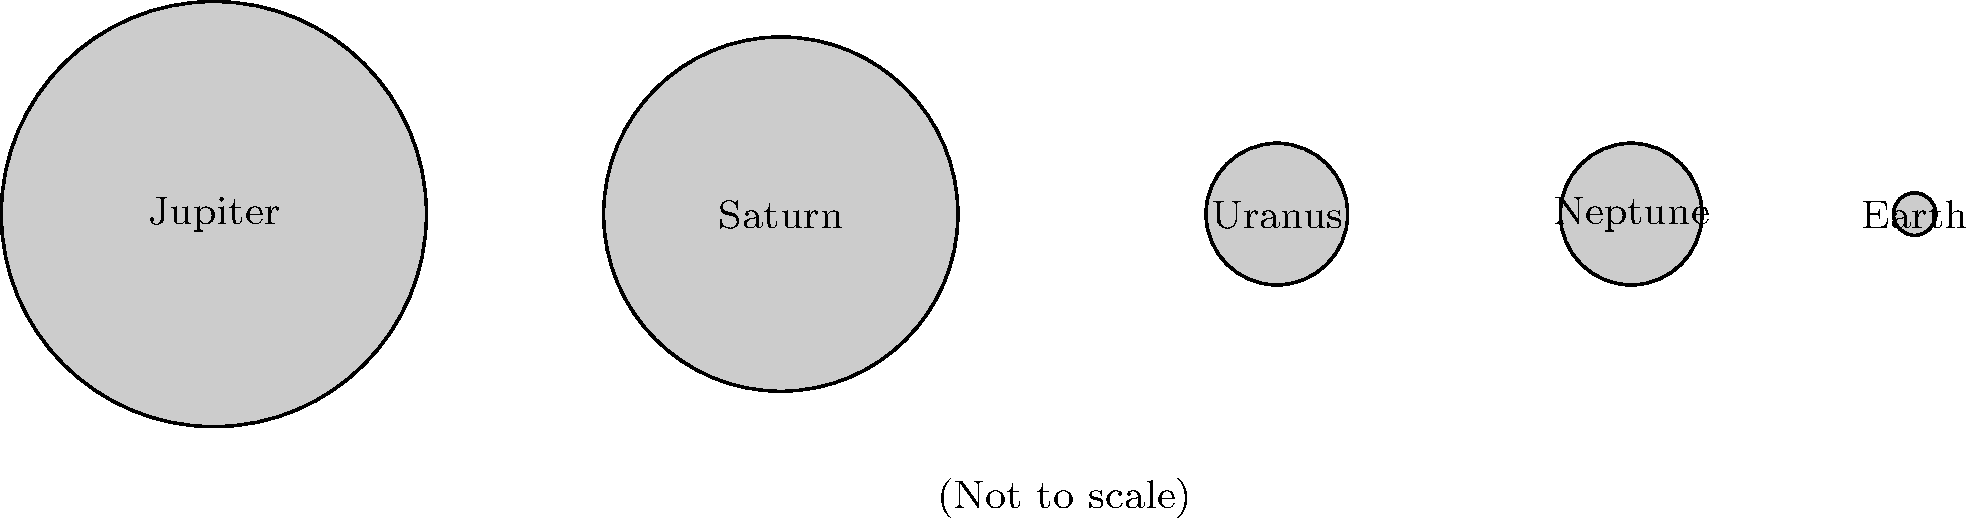As a pension fund manager experienced in analyzing complex data, consider the scaled representation of planets in our solar system shown above. If the diameter of Jupiter is approximately 11 times that of Earth, what is the approximate ratio of Saturn's diameter to Earth's diameter based on this scaled representation? Let's approach this step-by-step:

1. First, we need to establish the scale relationship between Jupiter and Earth in the image:
   - Jupiter's diameter in the image: 3 units
   - Earth's diameter in the image: 0.3 units
   - Ratio in image: 3 / 0.3 = 10

2. We're told that Jupiter's actual diameter is 11 times Earth's. So we need to adjust our scale:
   - Scale factor = 11 / 10 = 1.1

3. Now, let's measure Saturn's diameter in the image:
   - Saturn's diameter in the image: 2.5 units

4. To find the ratio of Saturn to Earth, we divide Saturn's diameter by Earth's:
   $\frac{\text{Saturn diameter}}{\text{Earth diameter}} = \frac{2.5}{0.3} = 8.33$

5. Applying our scale factor:
   $8.33 \times 1.1 = 9.17$

Therefore, based on this scaled representation and the given information about Jupiter, Saturn's diameter is approximately 9.17 times that of Earth.
Answer: 9.17 times Earth's diameter 